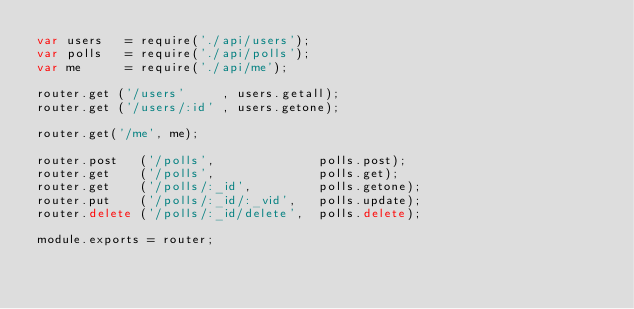Convert code to text. <code><loc_0><loc_0><loc_500><loc_500><_JavaScript_>var users   = require('./api/users');
var polls   = require('./api/polls');
var me      = require('./api/me');

router.get ('/users'     , users.getall);
router.get ('/users/:id' , users.getone);

router.get('/me', me);

router.post   ('/polls',              polls.post);
router.get    ('/polls',              polls.get);
router.get    ('/polls/:_id',         polls.getone);
router.put    ('/polls/:_id/:_vid',   polls.update);
router.delete ('/polls/:_id/delete',  polls.delete);

module.exports = router;
</code> 